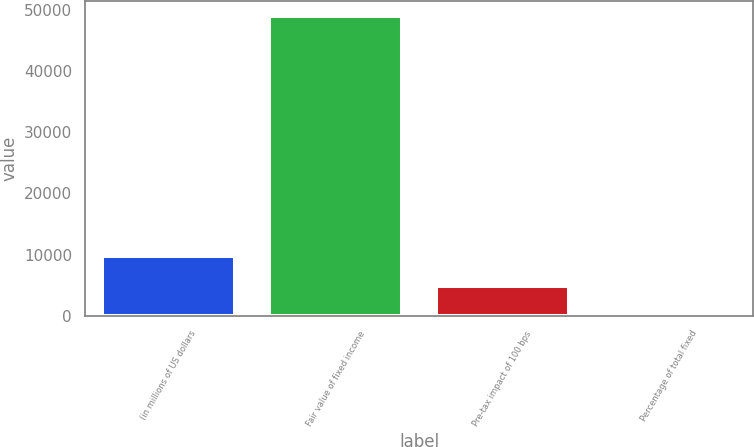Convert chart to OTSL. <chart><loc_0><loc_0><loc_500><loc_500><bar_chart><fcel>(in millions of US dollars<fcel>Fair value of fixed income<fcel>Pre-tax impact of 100 bps<fcel>Percentage of total fixed<nl><fcel>9799.56<fcel>48983<fcel>4901.63<fcel>3.7<nl></chart> 